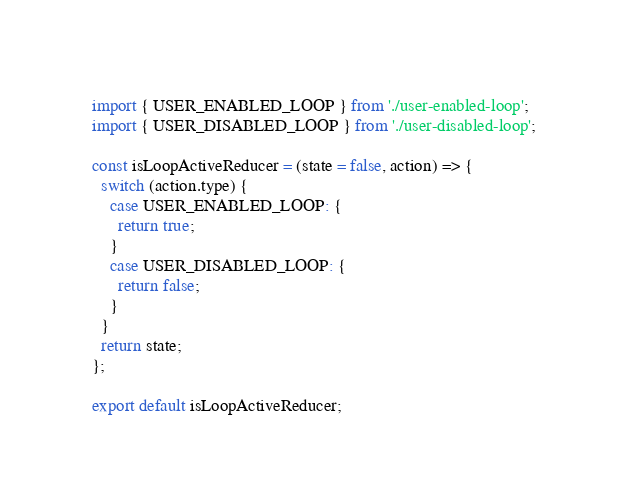Convert code to text. <code><loc_0><loc_0><loc_500><loc_500><_JavaScript_>import { USER_ENABLED_LOOP } from './user-enabled-loop';
import { USER_DISABLED_LOOP } from './user-disabled-loop';

const isLoopActiveReducer = (state = false, action) => {
  switch (action.type) {
    case USER_ENABLED_LOOP: {
      return true;
    }
    case USER_DISABLED_LOOP: {
      return false;
    }
  }
  return state;
};

export default isLoopActiveReducer;
</code> 